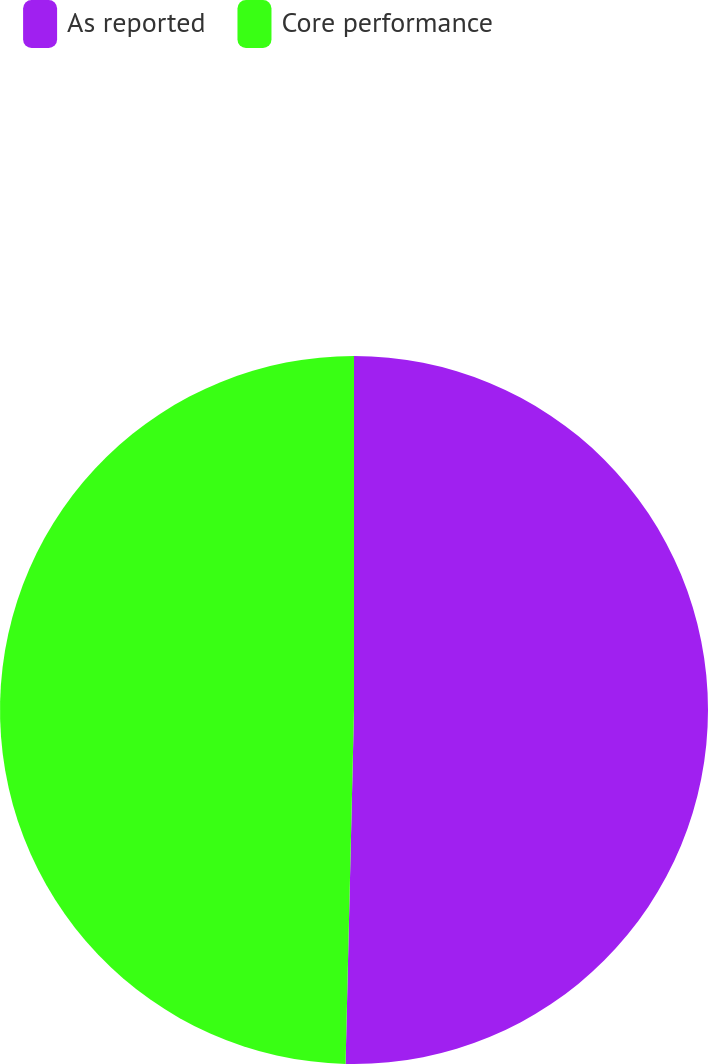Convert chart to OTSL. <chart><loc_0><loc_0><loc_500><loc_500><pie_chart><fcel>As reported<fcel>Core performance<nl><fcel>50.38%<fcel>49.62%<nl></chart> 